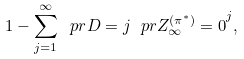<formula> <loc_0><loc_0><loc_500><loc_500>1 - \sum _ { j = 1 } ^ { \infty } \ p r { D = j } \ p r { Z ^ { ( \pi ^ { * } ) } _ { \infty } = 0 } ^ { j } ,</formula> 